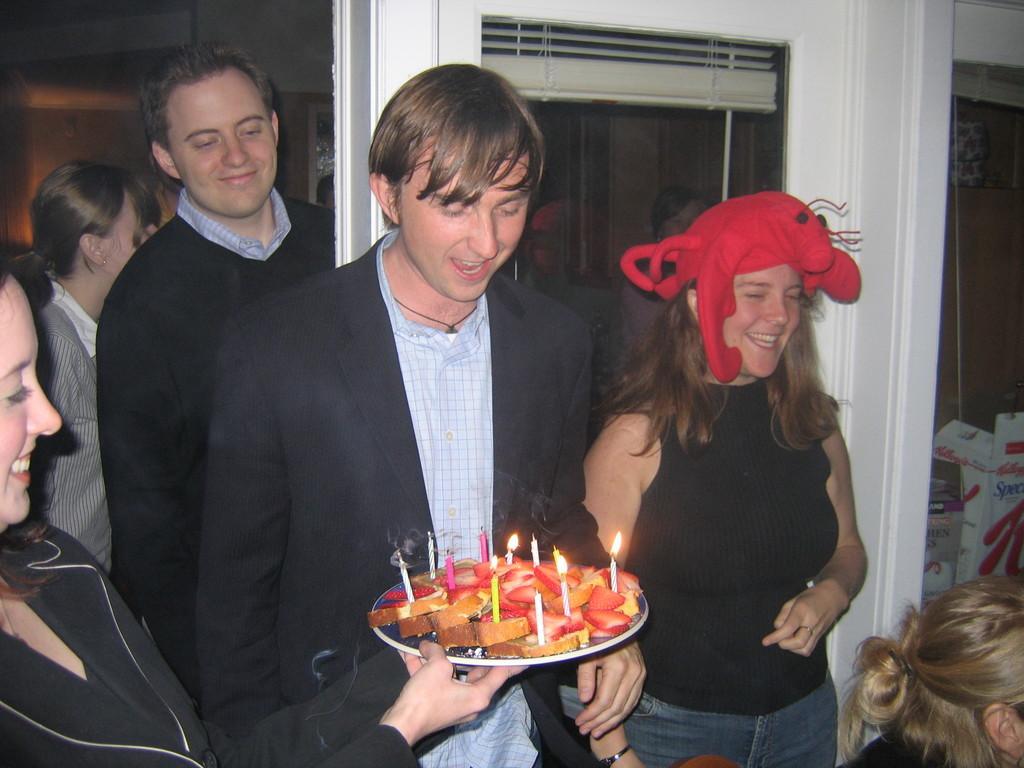Please provide a concise description of this image. In the image there are few people and among them the first woman is holding a plate with some breads and candles, behind them there is a window and on the right side there are some objects. 